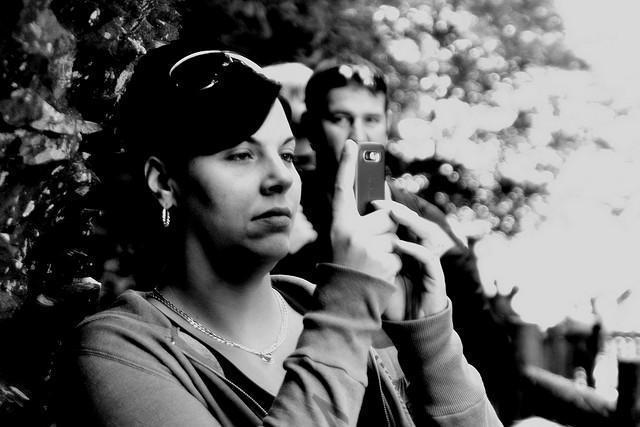How many people can be seen?
Give a very brief answer. 2. How many tracks have train cars on them?
Give a very brief answer. 0. 